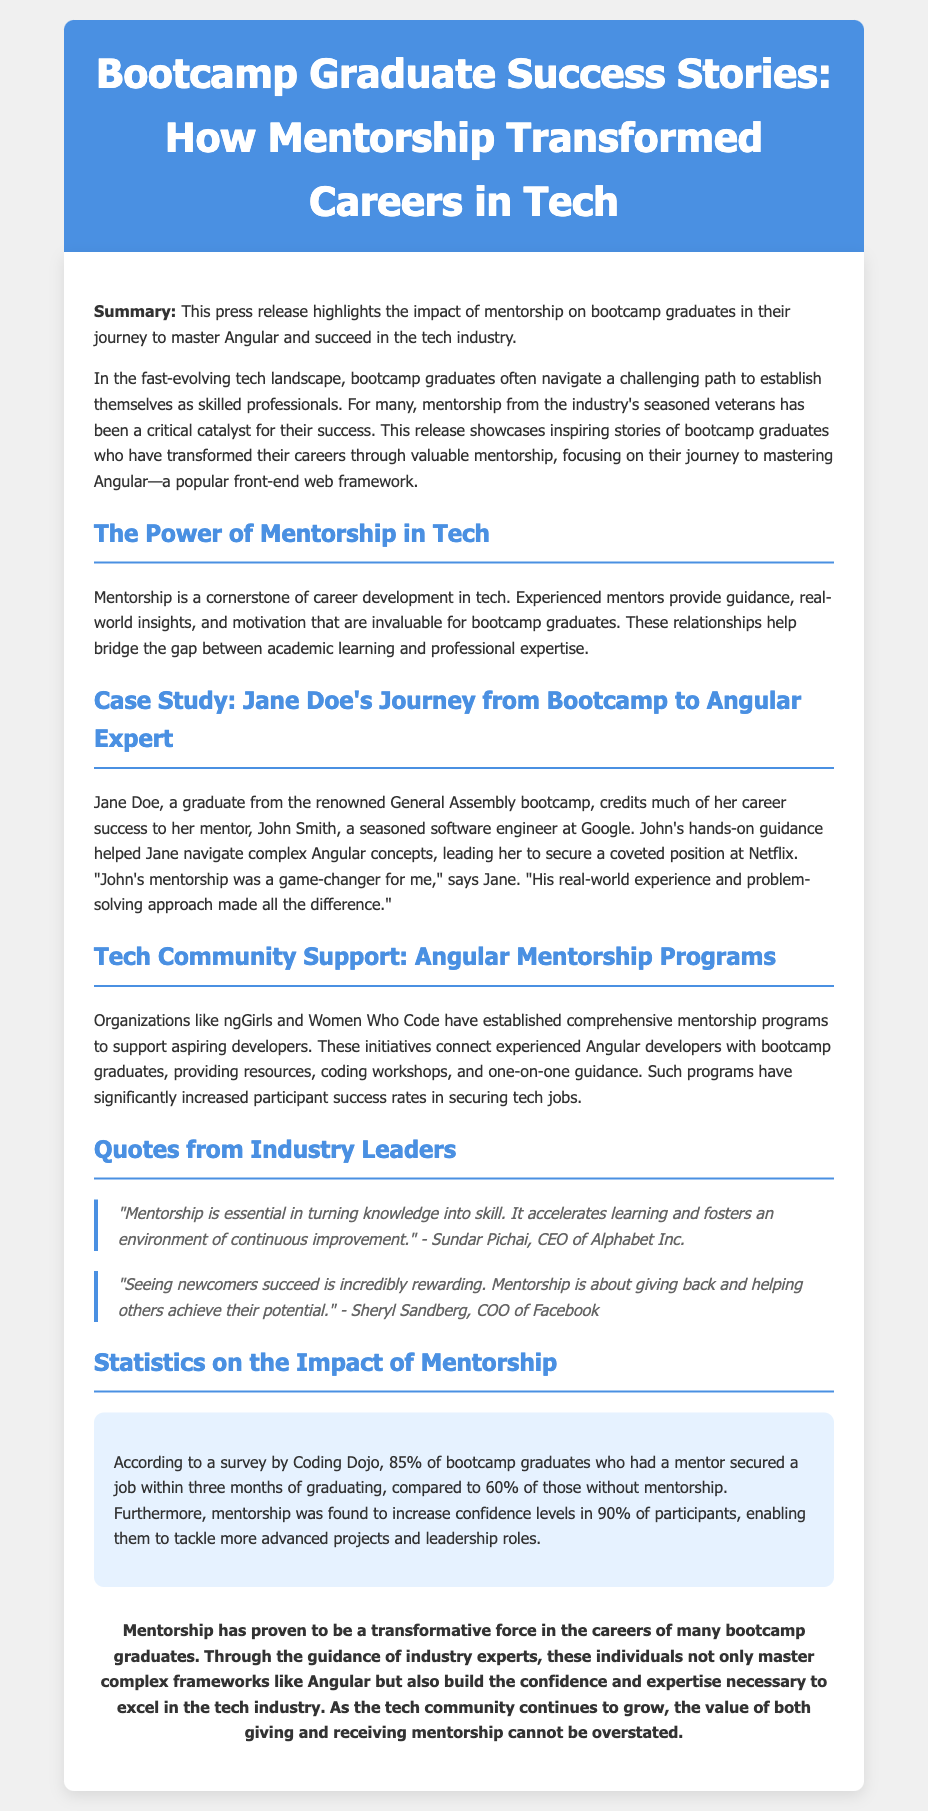What is the title of the press release? The title of the press release provides a summary of its focus and is prominently displayed at the top.
Answer: Bootcamp Graduate Success Stories: How Mentorship Transformed Careers in Tech Who is Jane Doe's mentor? This question seeks the name of the individual who provided mentorship to Jane Doe, as highlighted in her success story.
Answer: John Smith Which organization is mentioned as having a mentorship program for aspiring developers? The document discusses various organizations that offer mentorship support.
Answer: ngGirls What percentage of bootcamp graduates with a mentor secured a job within three months? The survey findings in the document provide specific statistical data related to mentorship success.
Answer: 85% What did Jane Doe say about her mentorship experience? This question looks for a direct quote from Jane Doe regarding the impact of mentorship on her career.
Answer: "John's mentorship was a game-changer for me." What is the significance of mentorship in the tech industry? This asks for the overall theme discussed in the document about mentorship's role in professional development.
Answer: A cornerstone of career development in tech 